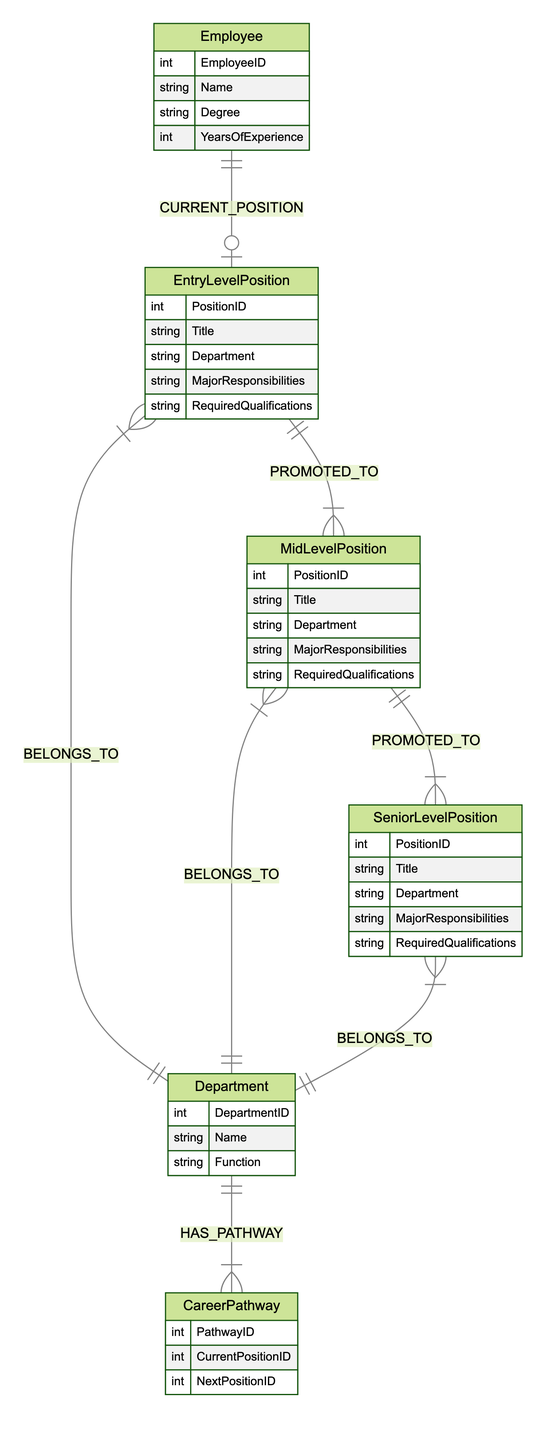What is the relationship between Employee and EntryLevelPosition? The diagram indicates that every Employee has a current position as an EntryLevelPosition, denoted by the relationship "CURRENT_POSITION". This means that for each employee, there is exactly one corresponding entry-level position they hold.
Answer: CURRENT_POSITION How many positions are in the MidLevelPosition entity? The diagram does not specify an explicit number of positions but indicates a relationship from EntryLevelPosition to MidLevelPosition, which means that multiple MidLevelPositions can exist since one entry-level position can lead to many mid-level positions.
Answer: Multiple What is the cardinality of the BELONGS_TO relationship? The BELONGS_TO relationship connects positions (EntryLevelPosition, MidLevelPosition, SeniorLevelPosition) to Departments. The cardinality is M:1, meaning many positions can belong to one department.
Answer: M:1 Which department has the relationship HAS_PATHWAY? The diagram shows that each Department can have multiple CareerPathways associated with it, as indicated by the relationship "HAS_PATHWAY". Therefore, all departments in the diagram will have career pathways.
Answer: All Departments What is the progression from an EntryLevelPosition to a SeniorLevelPosition? The diagram shows a clear pathway: an EntryLevelPosition can be promoted to multiple MidLevelPositions, and each MidLevelPosition can be promoted to multiple SeniorLevelPositions. Thus, the progression involves moving from entry to mid-level and then to senior level.
Answer: EntryLevel to MidLevel to SeniorLevel How many entities are involved in the entire diagram? The diagram consists of six entities: Employee, EntryLevelPosition, MidLevelPosition, SeniorLevelPosition, Department, and CareerPathway. By counting each named entity, we arrive at this total.
Answer: Six What is the primary attribute of the EntryLevelPosition? Within the EntryLevelPosition entity, the primary focus is on its PositionID, as it serves as the key identifier for each entry-level position. This is the most critical attribute among others listed.
Answer: PositionID Which relationship allows a MidLevelPosition to connect to a SeniorLevelPosition? The "PROMOTED_TO" relationship signifies how MidLevelPositions can be promoted to SeniorLevelPositions. This indicates that there’s a linkage between these levels based on career advancement.
Answer: PROMOTED_TO What is the total number of relationships in the diagram? By reviewing the relationships defined in the diagram, there are a total of seven relationships connecting the entities, including promotions and department affiliations.
Answer: Seven 